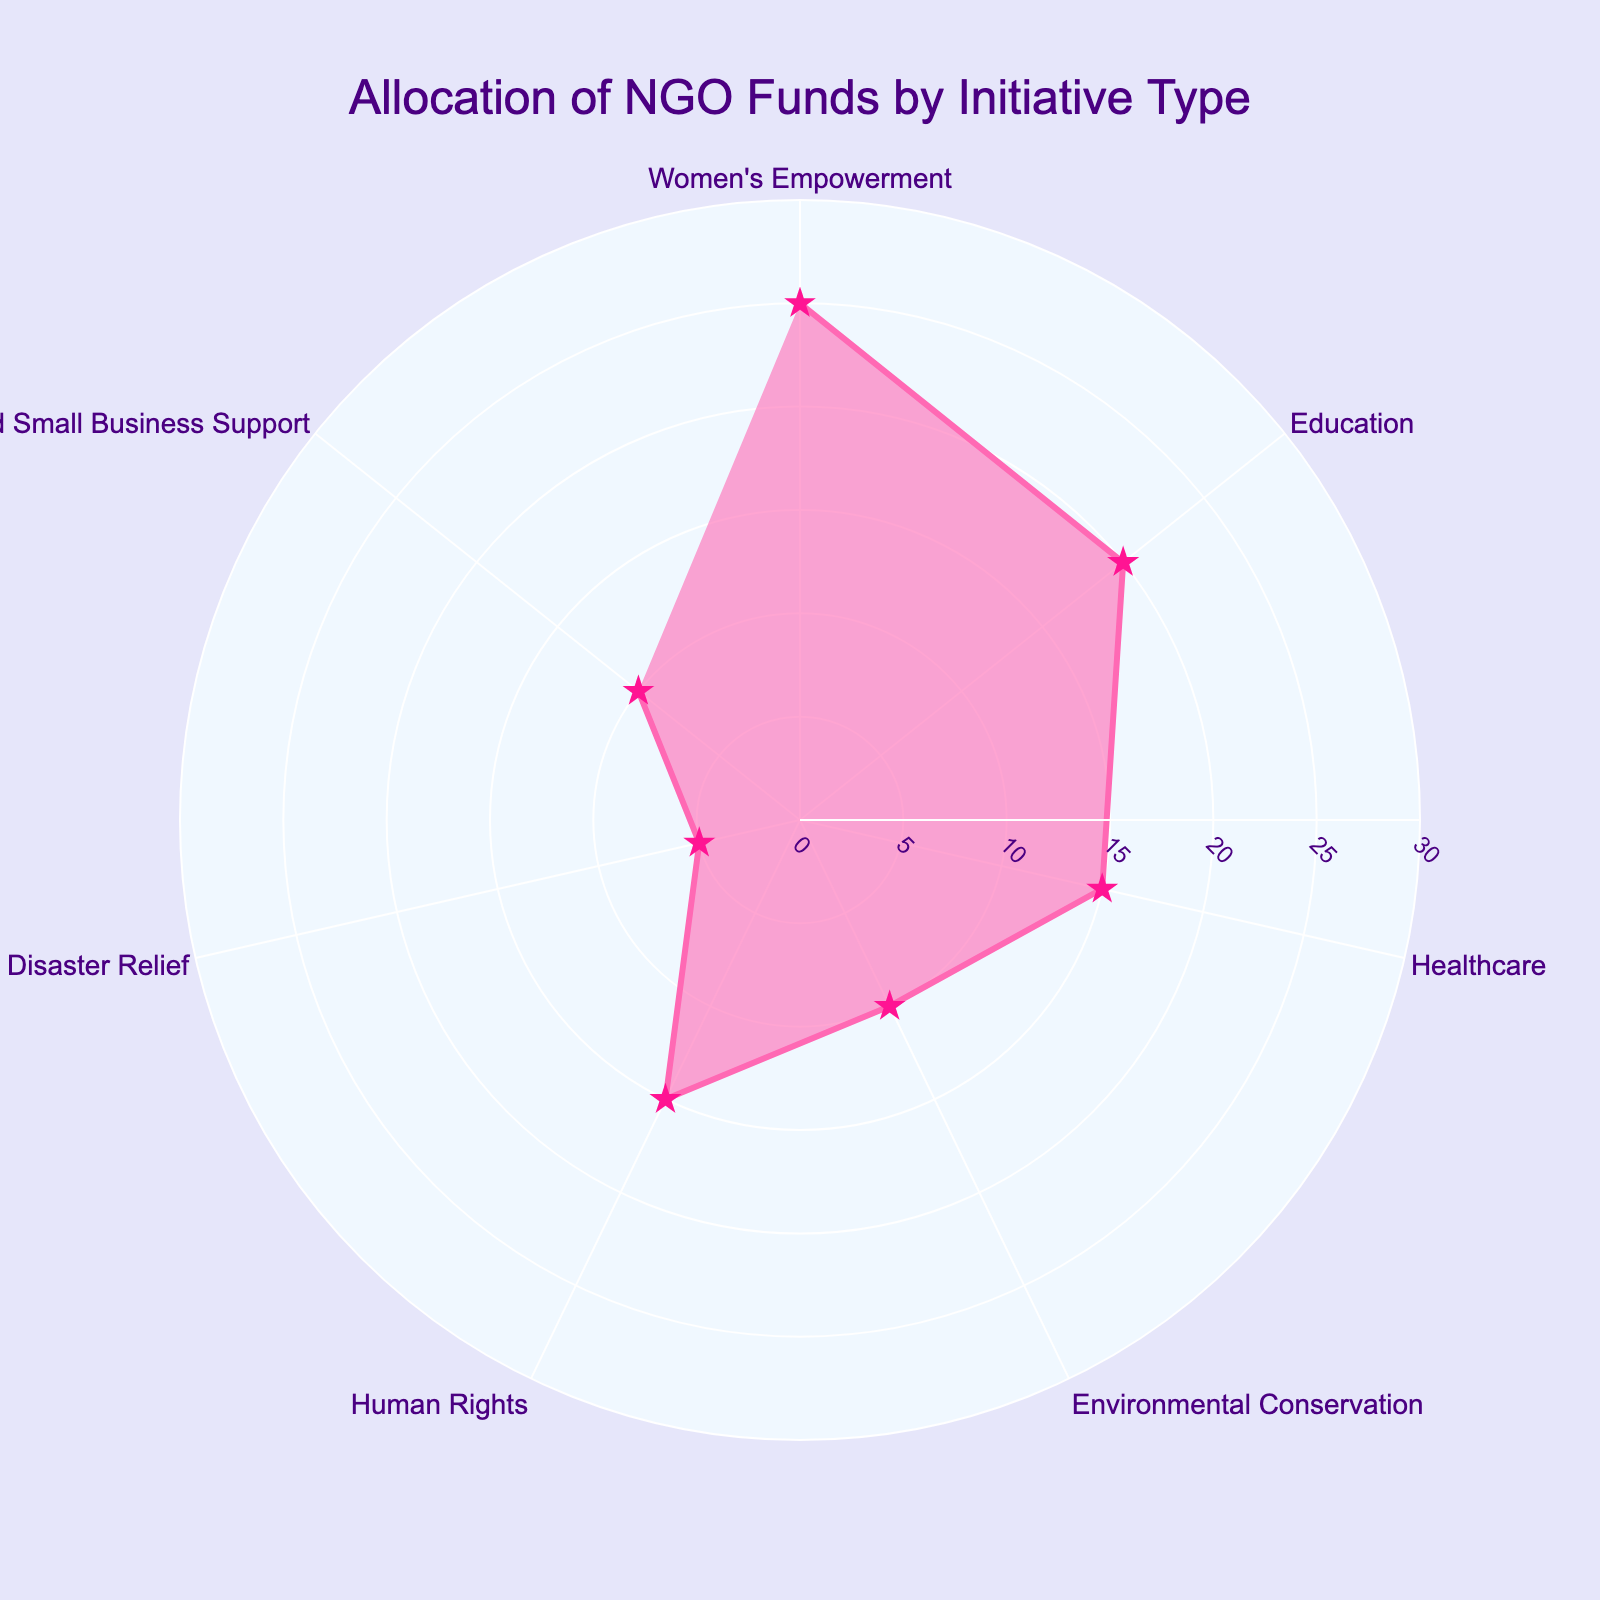what is the title of the figure? The title of the figure is located at the top of the chart, and it summarizes the main focus of the visualization
Answer: Allocation of NGO Funds by Initiative Type how many initiative types are shown on the chart? By counting the distinct segments around the polar chart, we can see how many different initiative types are represented
Answer: 7 which initiative type receives the highest percentage allocation? By examining which segment has the largest value on the radial axis, we can determine which initiative type receives the highest percentage allocation
Answer: Women's Empowerment how much more percentage allocation does Women's Empowerment receive compared to Disaster Relief? Subtract the percentage allocation of Disaster Relief from that of Women's Empowerment to find the difference
Answer: 20% which initiative types have equal percentage allocations? By identifying segments that extend to the same value on the radial axis, we can find which initiatives have equal allocations
Answer: Healthcare and Human Rights what is the combined percentage allocation for Education and Microfinance and Small Business Support? Add the percentage allocation values of Education and Microfinance and Small Business Support together to get the total
Answer: 30% is the percentage allocation for Environmental Conservation greater or less than that for Healthcare? Compare the values of Environmental Conservation and Healthcare on the radial axis to determine their relationship
Answer: Less what is the percentage allocation for the smallest initiative type? Identify the segment that reaches the lowest value on the radial axis to find the smallest initiative type's allocation
Answer: 5% how does the percentage allocation for Microfinance and Small Business Support compare to Environmental Conservation? Compare the values on the radial axis for these two segments to determine if one is greater than or less than the other
Answer: Equal what is the average percentage allocation across all initiative types? Sum the percentage allocations of all initiative types and then divide by the number of types to find the average
Answer: 100/7 ≈ 14.29% 